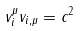<formula> <loc_0><loc_0><loc_500><loc_500>v ^ { \mu } _ { i } v _ { i , \mu } = c ^ { 2 }</formula> 